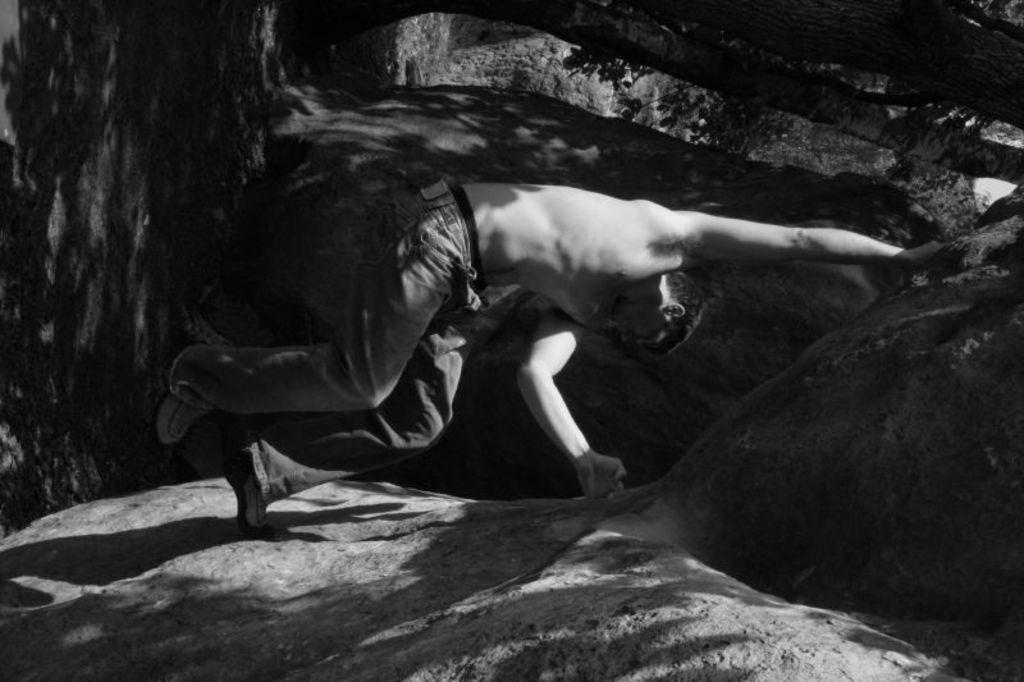What is the color scheme of the image? The image is black and white. What is the main subject of the image? There is a man in the image. What is the man doing in the image? The man is performing a stunt. What type of stunt is the man performing? The stunt involves a shoe rock. What type of clothing is the man wearing? The man is shirtless and wearing trousers and shoes. What type of game is the man playing in the image? There is no game being played in the image; the man is performing a stunt involving a shoe rock. What is the man's idea for a new invention in the image? There is no mention of an invention or idea in the image; the man is focused on performing a stunt. 